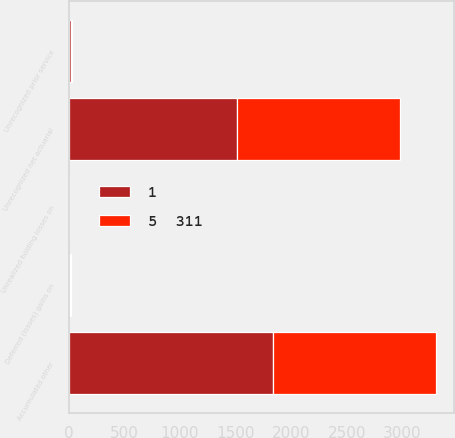Convert chart. <chart><loc_0><loc_0><loc_500><loc_500><stacked_bar_chart><ecel><fcel>Unrecognized net actuarial<fcel>Unrecognized prior service<fcel>Deferred (losses) gains on<fcel>Unrealized holding losses on<fcel>Accumulated other<nl><fcel>5  311<fcel>1460<fcel>16<fcel>3<fcel>2<fcel>1466<nl><fcel>1<fcel>1516<fcel>17<fcel>14<fcel>3<fcel>1833<nl></chart> 